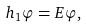<formula> <loc_0><loc_0><loc_500><loc_500>h _ { 1 } \varphi = E \varphi ,</formula> 